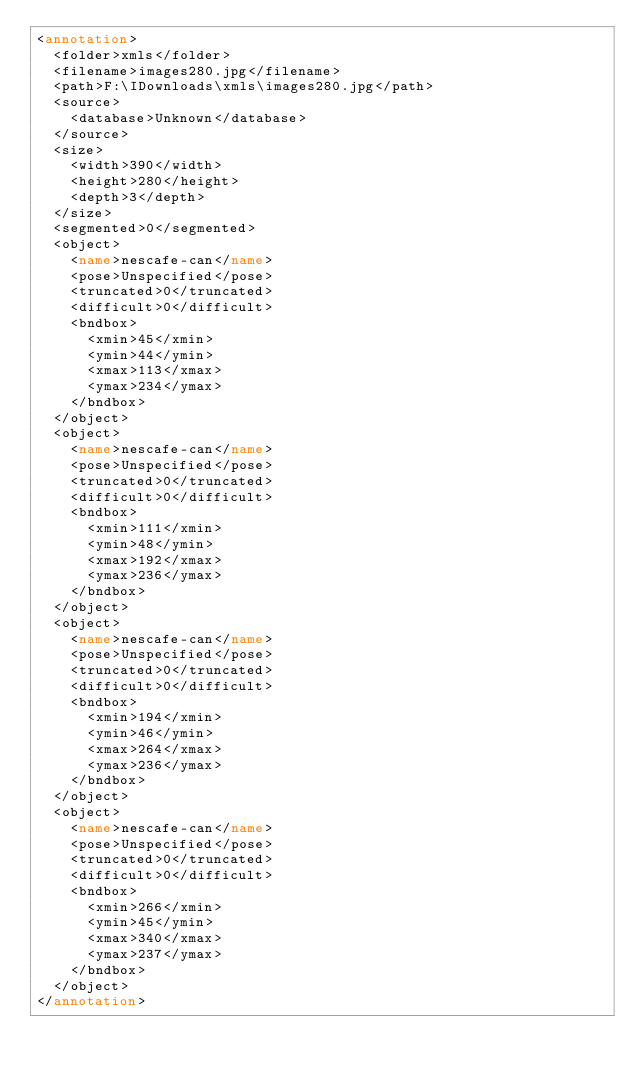Convert code to text. <code><loc_0><loc_0><loc_500><loc_500><_XML_><annotation>
	<folder>xmls</folder>
	<filename>images280.jpg</filename>
	<path>F:\IDownloads\xmls\images280.jpg</path>
	<source>
		<database>Unknown</database>
	</source>
	<size>
		<width>390</width>
		<height>280</height>
		<depth>3</depth>
	</size>
	<segmented>0</segmented>
	<object>
		<name>nescafe-can</name>
		<pose>Unspecified</pose>
		<truncated>0</truncated>
		<difficult>0</difficult>
		<bndbox>
			<xmin>45</xmin>
			<ymin>44</ymin>
			<xmax>113</xmax>
			<ymax>234</ymax>
		</bndbox>
	</object>
	<object>
		<name>nescafe-can</name>
		<pose>Unspecified</pose>
		<truncated>0</truncated>
		<difficult>0</difficult>
		<bndbox>
			<xmin>111</xmin>
			<ymin>48</ymin>
			<xmax>192</xmax>
			<ymax>236</ymax>
		</bndbox>
	</object>
	<object>
		<name>nescafe-can</name>
		<pose>Unspecified</pose>
		<truncated>0</truncated>
		<difficult>0</difficult>
		<bndbox>
			<xmin>194</xmin>
			<ymin>46</ymin>
			<xmax>264</xmax>
			<ymax>236</ymax>
		</bndbox>
	</object>
	<object>
		<name>nescafe-can</name>
		<pose>Unspecified</pose>
		<truncated>0</truncated>
		<difficult>0</difficult>
		<bndbox>
			<xmin>266</xmin>
			<ymin>45</ymin>
			<xmax>340</xmax>
			<ymax>237</ymax>
		</bndbox>
	</object>
</annotation>
</code> 